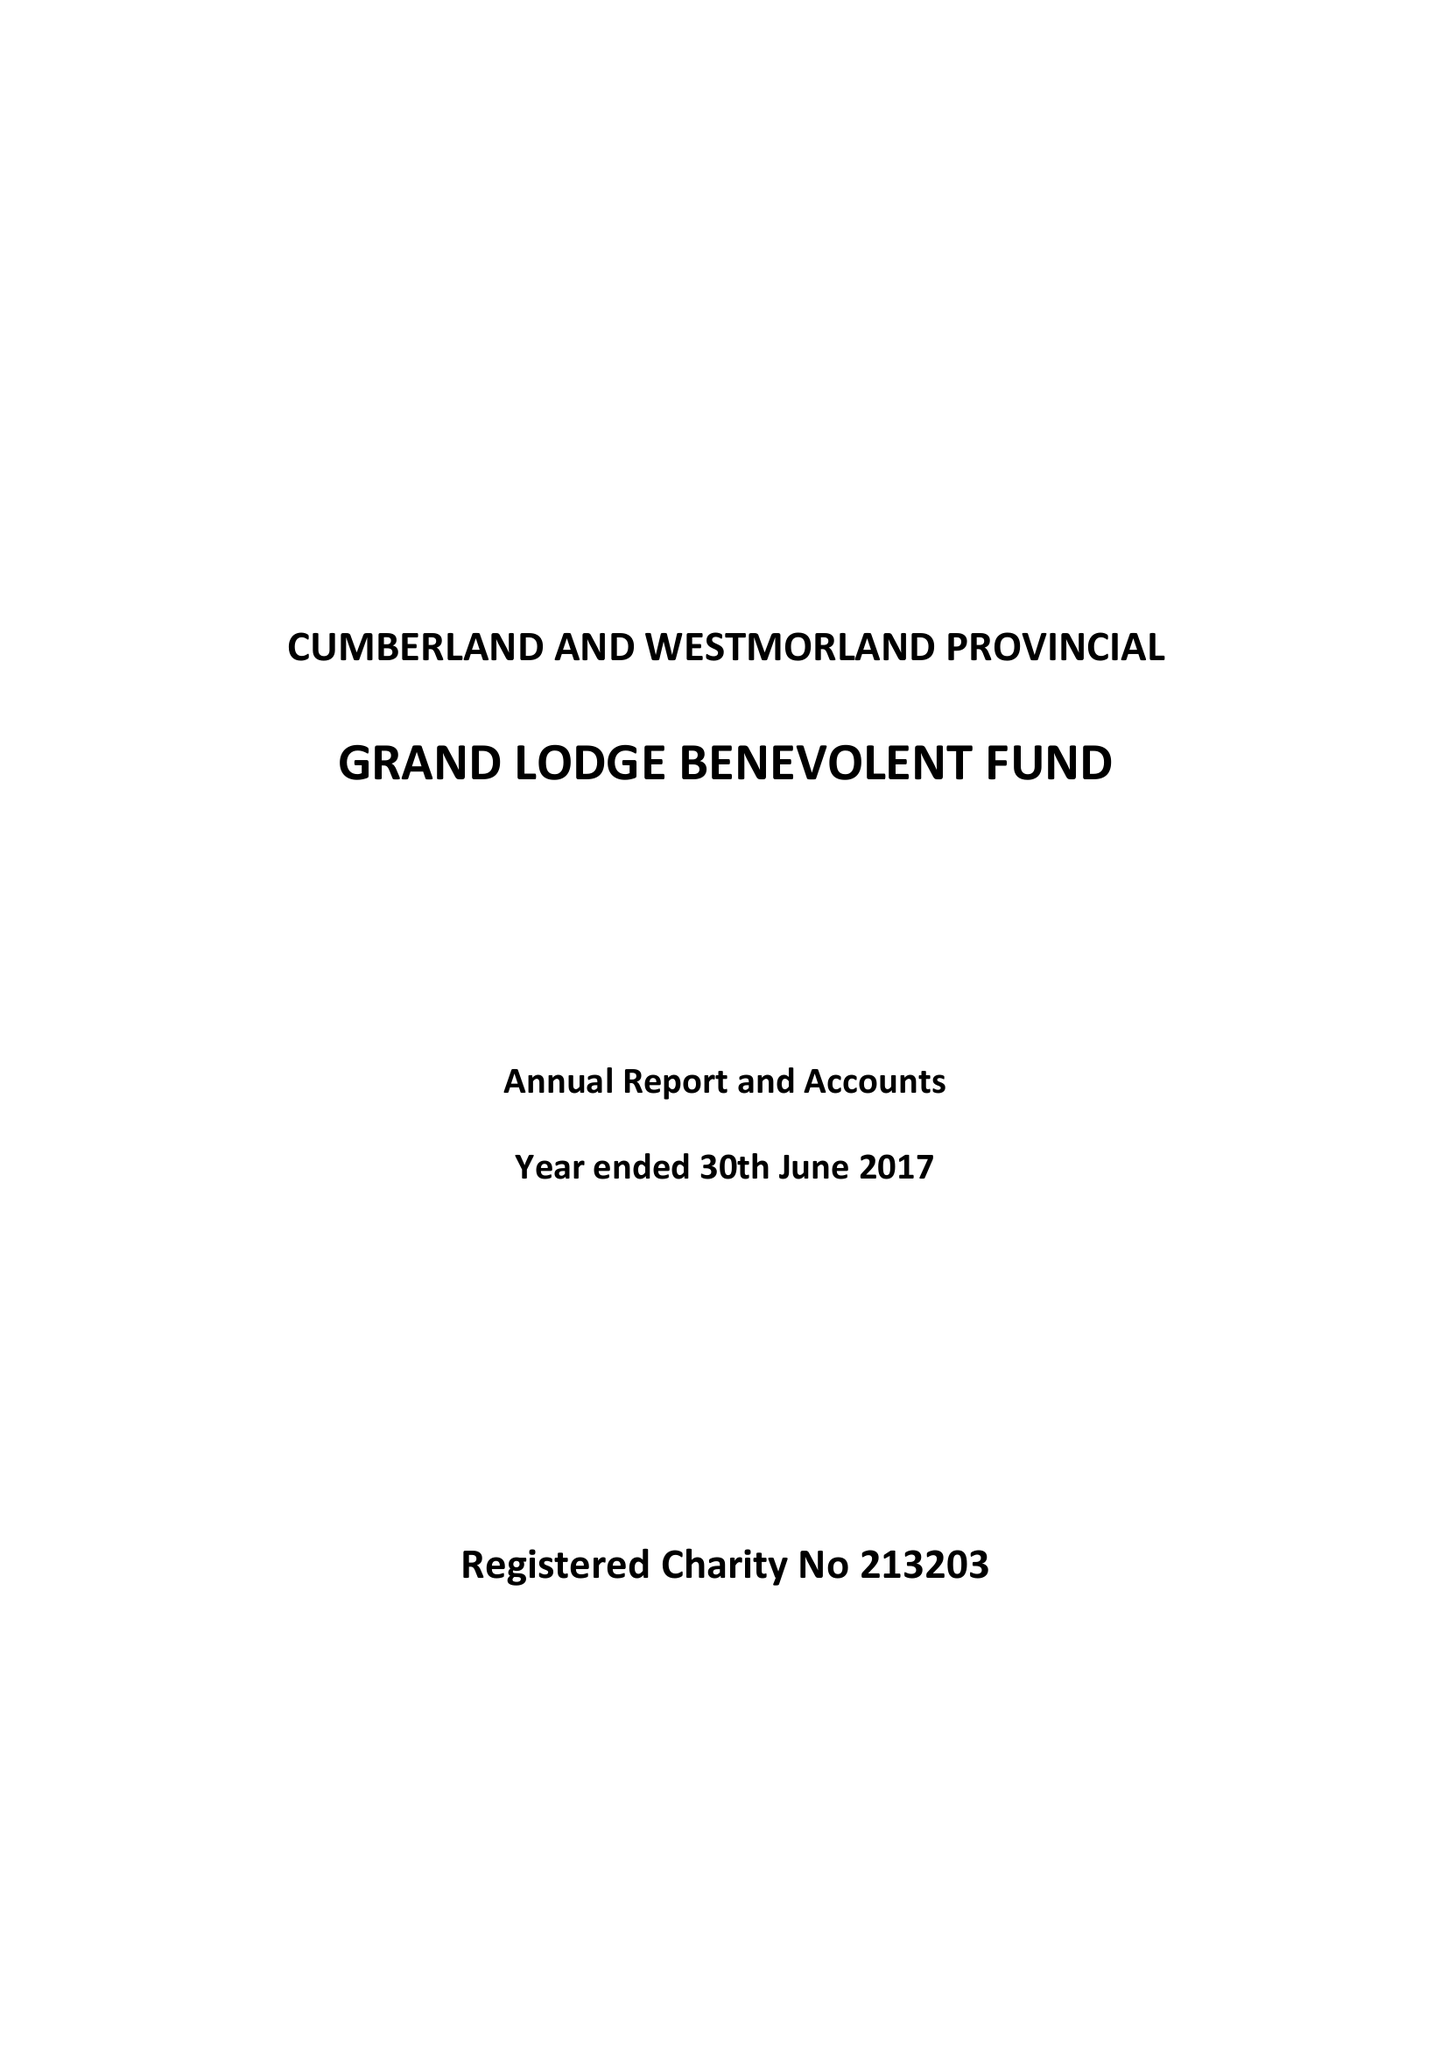What is the value for the address__postcode?
Answer the question using a single word or phrase. CA5 7HS 